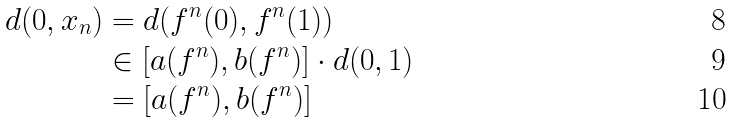Convert formula to latex. <formula><loc_0><loc_0><loc_500><loc_500>d ( 0 , x _ { n } ) & = d ( f ^ { n } ( 0 ) , f ^ { n } ( 1 ) ) \\ & \in [ a ( f ^ { n } ) , b ( f ^ { n } ) ] \cdot d ( 0 , 1 ) \\ & = [ a ( f ^ { n } ) , b ( f ^ { n } ) ]</formula> 